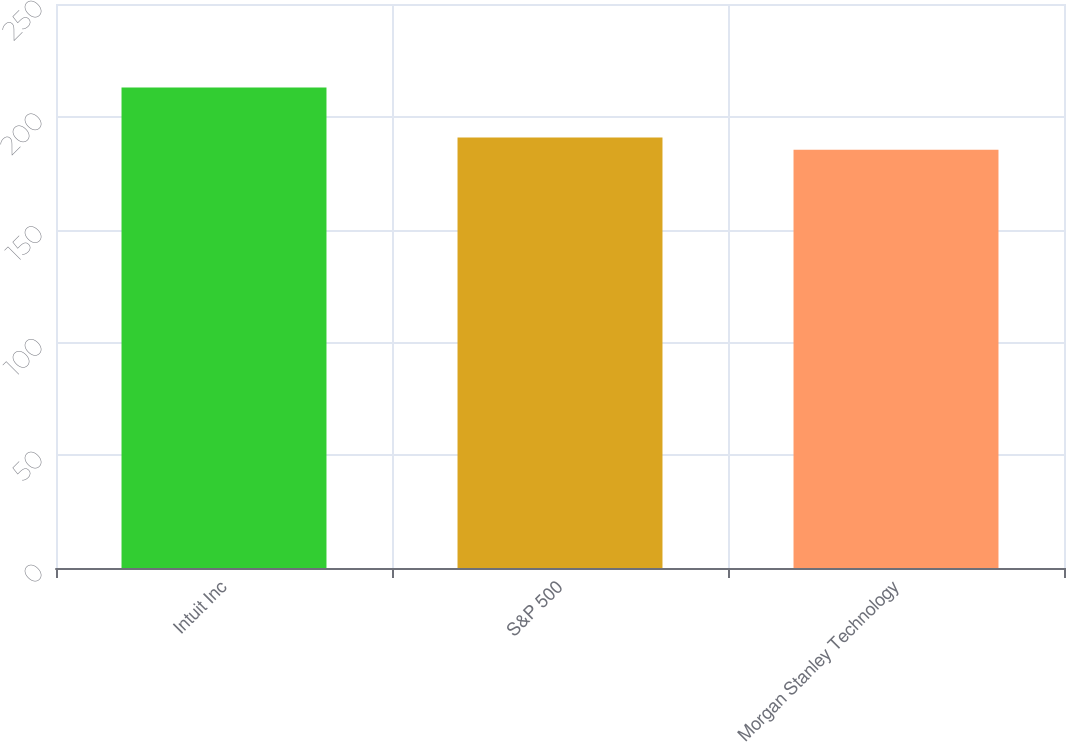Convert chart to OTSL. <chart><loc_0><loc_0><loc_500><loc_500><bar_chart><fcel>Intuit Inc<fcel>S&P 500<fcel>Morgan Stanley Technology<nl><fcel>212.97<fcel>190.87<fcel>185.39<nl></chart> 